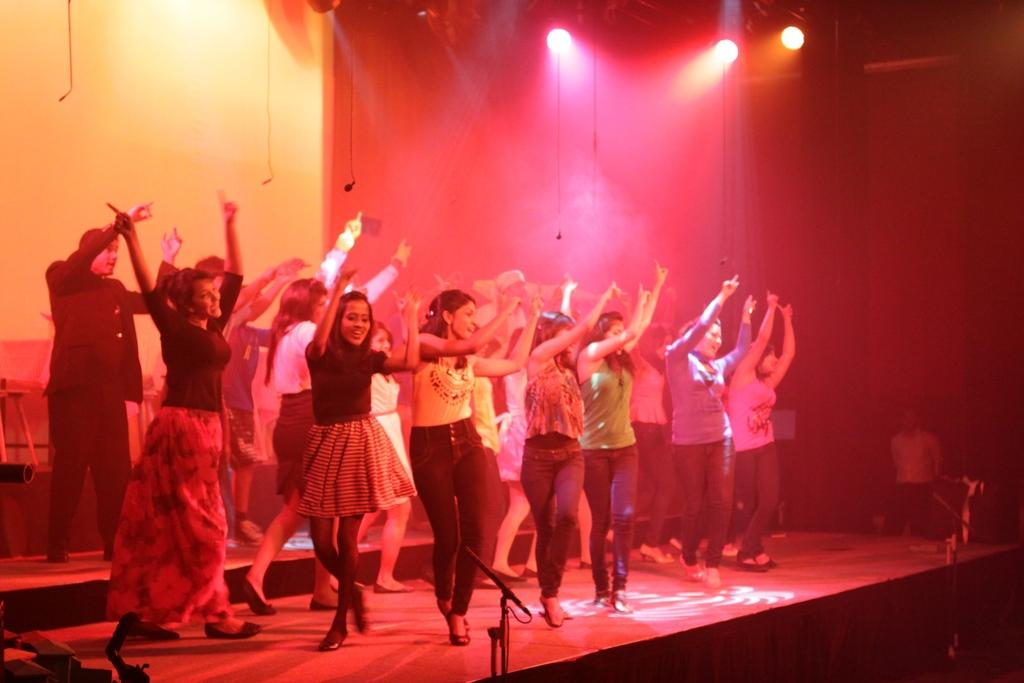What is the person in the image doing? The person is riding a bicycle. What can be seen in the background of the image? There is a road and trees in the background. What is the color of the sky in the image? The sky is blue in the image. What historical event is the person on the bicycle commemorating in the image? There is no indication of a historical event or commemoration in the image. What type of musical instrument is the person playing while riding the bicycle? The person is not playing any musical instrument in the image. 